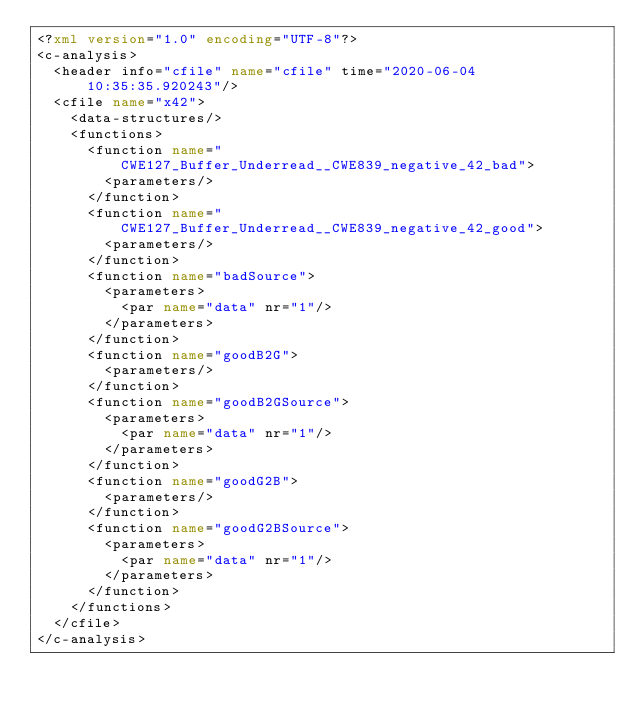<code> <loc_0><loc_0><loc_500><loc_500><_XML_><?xml version="1.0" encoding="UTF-8"?>
<c-analysis>
  <header info="cfile" name="cfile" time="2020-06-04 10:35:35.920243"/>
  <cfile name="x42">
    <data-structures/>
    <functions>
      <function name="CWE127_Buffer_Underread__CWE839_negative_42_bad">
        <parameters/>
      </function>
      <function name="CWE127_Buffer_Underread__CWE839_negative_42_good">
        <parameters/>
      </function>
      <function name="badSource">
        <parameters>
          <par name="data" nr="1"/>
        </parameters>
      </function>
      <function name="goodB2G">
        <parameters/>
      </function>
      <function name="goodB2GSource">
        <parameters>
          <par name="data" nr="1"/>
        </parameters>
      </function>
      <function name="goodG2B">
        <parameters/>
      </function>
      <function name="goodG2BSource">
        <parameters>
          <par name="data" nr="1"/>
        </parameters>
      </function>
    </functions>
  </cfile>
</c-analysis>
</code> 